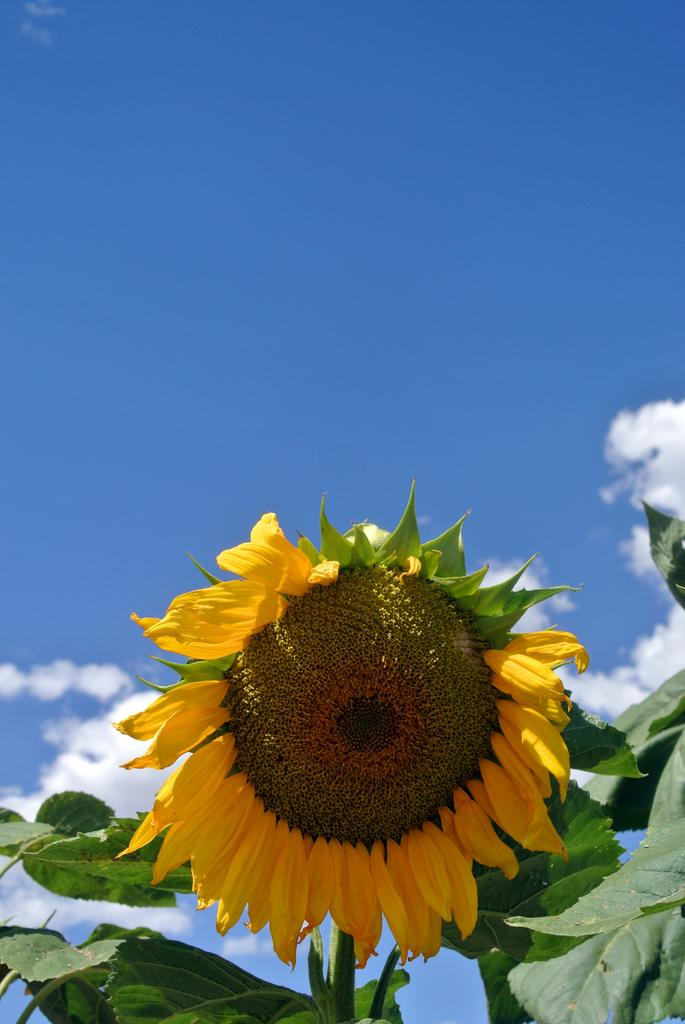What type of living organism is present in the image? There is a plant in the image. What specific features can be observed on the plant? The plant has a flower and leaves. What can be seen in the background of the image? The background of the image includes the sky. What is the condition of the sky in the image? There are clouds in the sky. Can you tell me where the badge is located on the plant in the image? There is no badge present on the plant in the image. What type of amusement can be seen on the stage in the image? There is no stage or amusement present in the image; it features a plant with a flower and leaves, and a sky with clouds. 